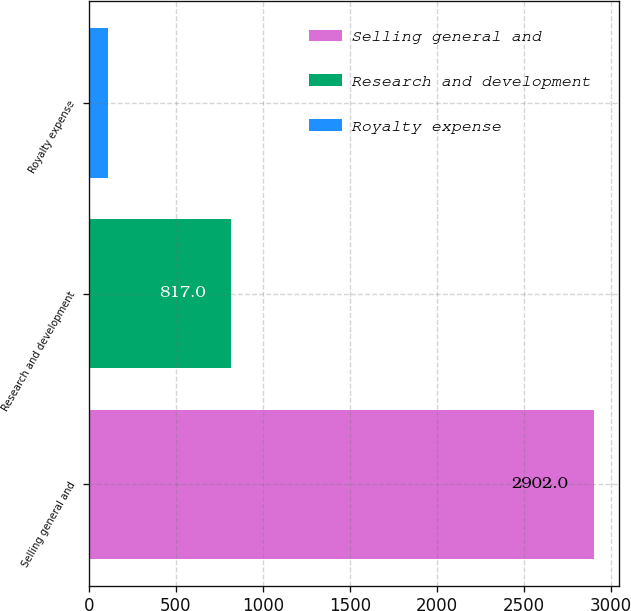<chart> <loc_0><loc_0><loc_500><loc_500><bar_chart><fcel>Selling general and<fcel>Research and development<fcel>Royalty expense<nl><fcel>2902<fcel>817<fcel>111<nl></chart> 